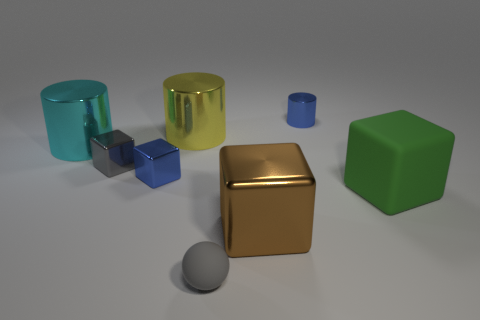Is there a large brown metallic block?
Keep it short and to the point. Yes. There is a blue metallic object behind the cyan object; is its size the same as the large cyan metallic object?
Offer a terse response. No. Is the number of tiny metallic objects less than the number of large yellow shiny objects?
Your answer should be compact. No. The rubber thing that is right of the rubber object that is in front of the big thing to the right of the small metal cylinder is what shape?
Offer a very short reply. Cube. Are there any objects that have the same material as the tiny cylinder?
Your response must be concise. Yes. There is a thing that is on the right side of the tiny blue metal cylinder; is its color the same as the large cylinder on the right side of the large cyan object?
Offer a very short reply. No. Are there fewer brown metal things to the left of the cyan object than tiny metallic cubes?
Your answer should be very brief. Yes. How many things are either large yellow metal cylinders or small shiny things to the right of the big brown shiny cube?
Offer a terse response. 2. There is a large block that is made of the same material as the tiny gray block; what color is it?
Your answer should be very brief. Brown. What number of things are either shiny cylinders or small red cubes?
Offer a very short reply. 3. 